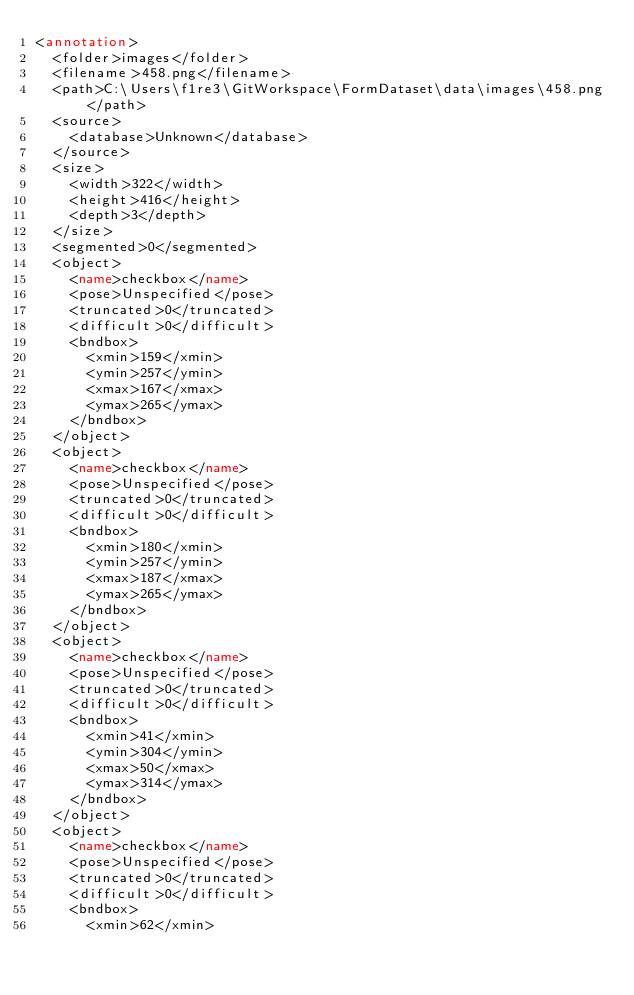Convert code to text. <code><loc_0><loc_0><loc_500><loc_500><_XML_><annotation>
	<folder>images</folder>
	<filename>458.png</filename>
	<path>C:\Users\f1re3\GitWorkspace\FormDataset\data\images\458.png</path>
	<source>
		<database>Unknown</database>
	</source>
	<size>
		<width>322</width>
		<height>416</height>
		<depth>3</depth>
	</size>
	<segmented>0</segmented>
	<object>
		<name>checkbox</name>
		<pose>Unspecified</pose>
		<truncated>0</truncated>
		<difficult>0</difficult>
		<bndbox>
			<xmin>159</xmin>
			<ymin>257</ymin>
			<xmax>167</xmax>
			<ymax>265</ymax>
		</bndbox>
	</object>
	<object>
		<name>checkbox</name>
		<pose>Unspecified</pose>
		<truncated>0</truncated>
		<difficult>0</difficult>
		<bndbox>
			<xmin>180</xmin>
			<ymin>257</ymin>
			<xmax>187</xmax>
			<ymax>265</ymax>
		</bndbox>
	</object>
	<object>
		<name>checkbox</name>
		<pose>Unspecified</pose>
		<truncated>0</truncated>
		<difficult>0</difficult>
		<bndbox>
			<xmin>41</xmin>
			<ymin>304</ymin>
			<xmax>50</xmax>
			<ymax>314</ymax>
		</bndbox>
	</object>
	<object>
		<name>checkbox</name>
		<pose>Unspecified</pose>
		<truncated>0</truncated>
		<difficult>0</difficult>
		<bndbox>
			<xmin>62</xmin></code> 